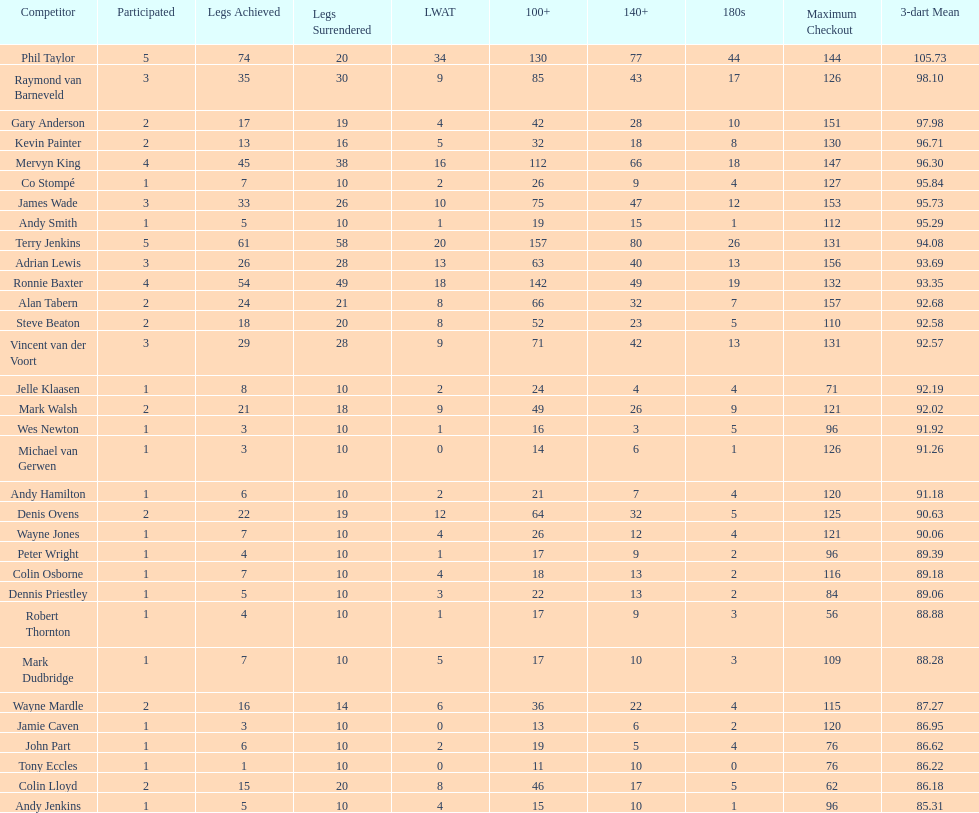How many players have a 3 dart average of more than 97? 3. 